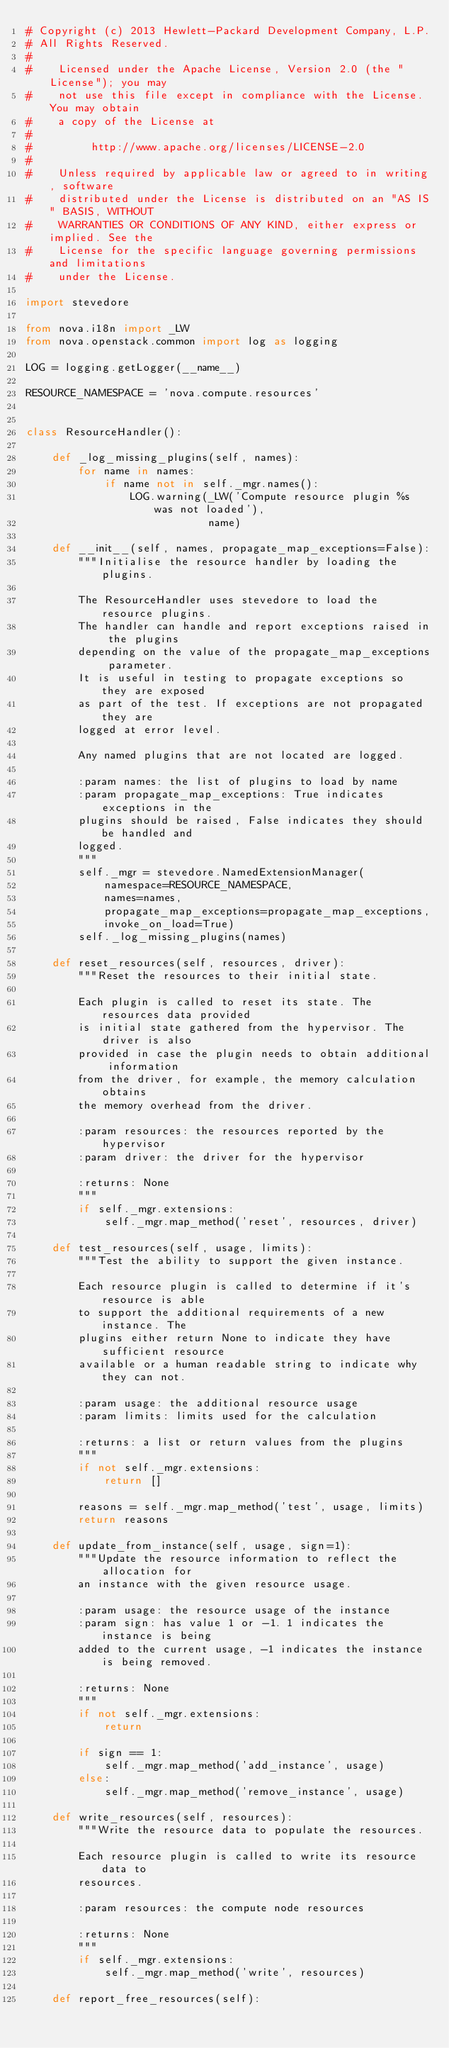<code> <loc_0><loc_0><loc_500><loc_500><_Python_># Copyright (c) 2013 Hewlett-Packard Development Company, L.P.
# All Rights Reserved.
#
#    Licensed under the Apache License, Version 2.0 (the "License"); you may
#    not use this file except in compliance with the License. You may obtain
#    a copy of the License at
#
#         http://www.apache.org/licenses/LICENSE-2.0
#
#    Unless required by applicable law or agreed to in writing, software
#    distributed under the License is distributed on an "AS IS" BASIS, WITHOUT
#    WARRANTIES OR CONDITIONS OF ANY KIND, either express or implied. See the
#    License for the specific language governing permissions and limitations
#    under the License.

import stevedore

from nova.i18n import _LW
from nova.openstack.common import log as logging

LOG = logging.getLogger(__name__)

RESOURCE_NAMESPACE = 'nova.compute.resources'


class ResourceHandler():

    def _log_missing_plugins(self, names):
        for name in names:
            if name not in self._mgr.names():
                LOG.warning(_LW('Compute resource plugin %s was not loaded'),
                            name)

    def __init__(self, names, propagate_map_exceptions=False):
        """Initialise the resource handler by loading the plugins.

        The ResourceHandler uses stevedore to load the resource plugins.
        The handler can handle and report exceptions raised in the plugins
        depending on the value of the propagate_map_exceptions parameter.
        It is useful in testing to propagate exceptions so they are exposed
        as part of the test. If exceptions are not propagated they are
        logged at error level.

        Any named plugins that are not located are logged.

        :param names: the list of plugins to load by name
        :param propagate_map_exceptions: True indicates exceptions in the
        plugins should be raised, False indicates they should be handled and
        logged.
        """
        self._mgr = stevedore.NamedExtensionManager(
            namespace=RESOURCE_NAMESPACE,
            names=names,
            propagate_map_exceptions=propagate_map_exceptions,
            invoke_on_load=True)
        self._log_missing_plugins(names)

    def reset_resources(self, resources, driver):
        """Reset the resources to their initial state.

        Each plugin is called to reset its state. The resources data provided
        is initial state gathered from the hypervisor. The driver is also
        provided in case the plugin needs to obtain additional information
        from the driver, for example, the memory calculation obtains
        the memory overhead from the driver.

        :param resources: the resources reported by the hypervisor
        :param driver: the driver for the hypervisor

        :returns: None
        """
        if self._mgr.extensions:
            self._mgr.map_method('reset', resources, driver)

    def test_resources(self, usage, limits):
        """Test the ability to support the given instance.

        Each resource plugin is called to determine if it's resource is able
        to support the additional requirements of a new instance. The
        plugins either return None to indicate they have sufficient resource
        available or a human readable string to indicate why they can not.

        :param usage: the additional resource usage
        :param limits: limits used for the calculation

        :returns: a list or return values from the plugins
        """
        if not self._mgr.extensions:
            return []

        reasons = self._mgr.map_method('test', usage, limits)
        return reasons

    def update_from_instance(self, usage, sign=1):
        """Update the resource information to reflect the allocation for
        an instance with the given resource usage.

        :param usage: the resource usage of the instance
        :param sign: has value 1 or -1. 1 indicates the instance is being
        added to the current usage, -1 indicates the instance is being removed.

        :returns: None
        """
        if not self._mgr.extensions:
            return

        if sign == 1:
            self._mgr.map_method('add_instance', usage)
        else:
            self._mgr.map_method('remove_instance', usage)

    def write_resources(self, resources):
        """Write the resource data to populate the resources.

        Each resource plugin is called to write its resource data to
        resources.

        :param resources: the compute node resources

        :returns: None
        """
        if self._mgr.extensions:
            self._mgr.map_method('write', resources)

    def report_free_resources(self):</code> 